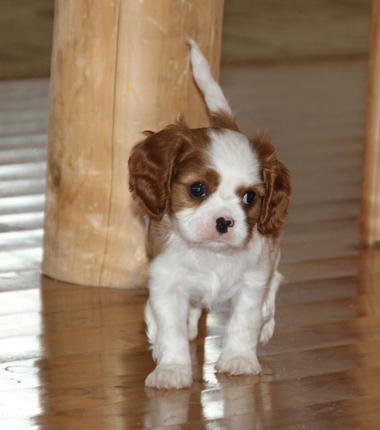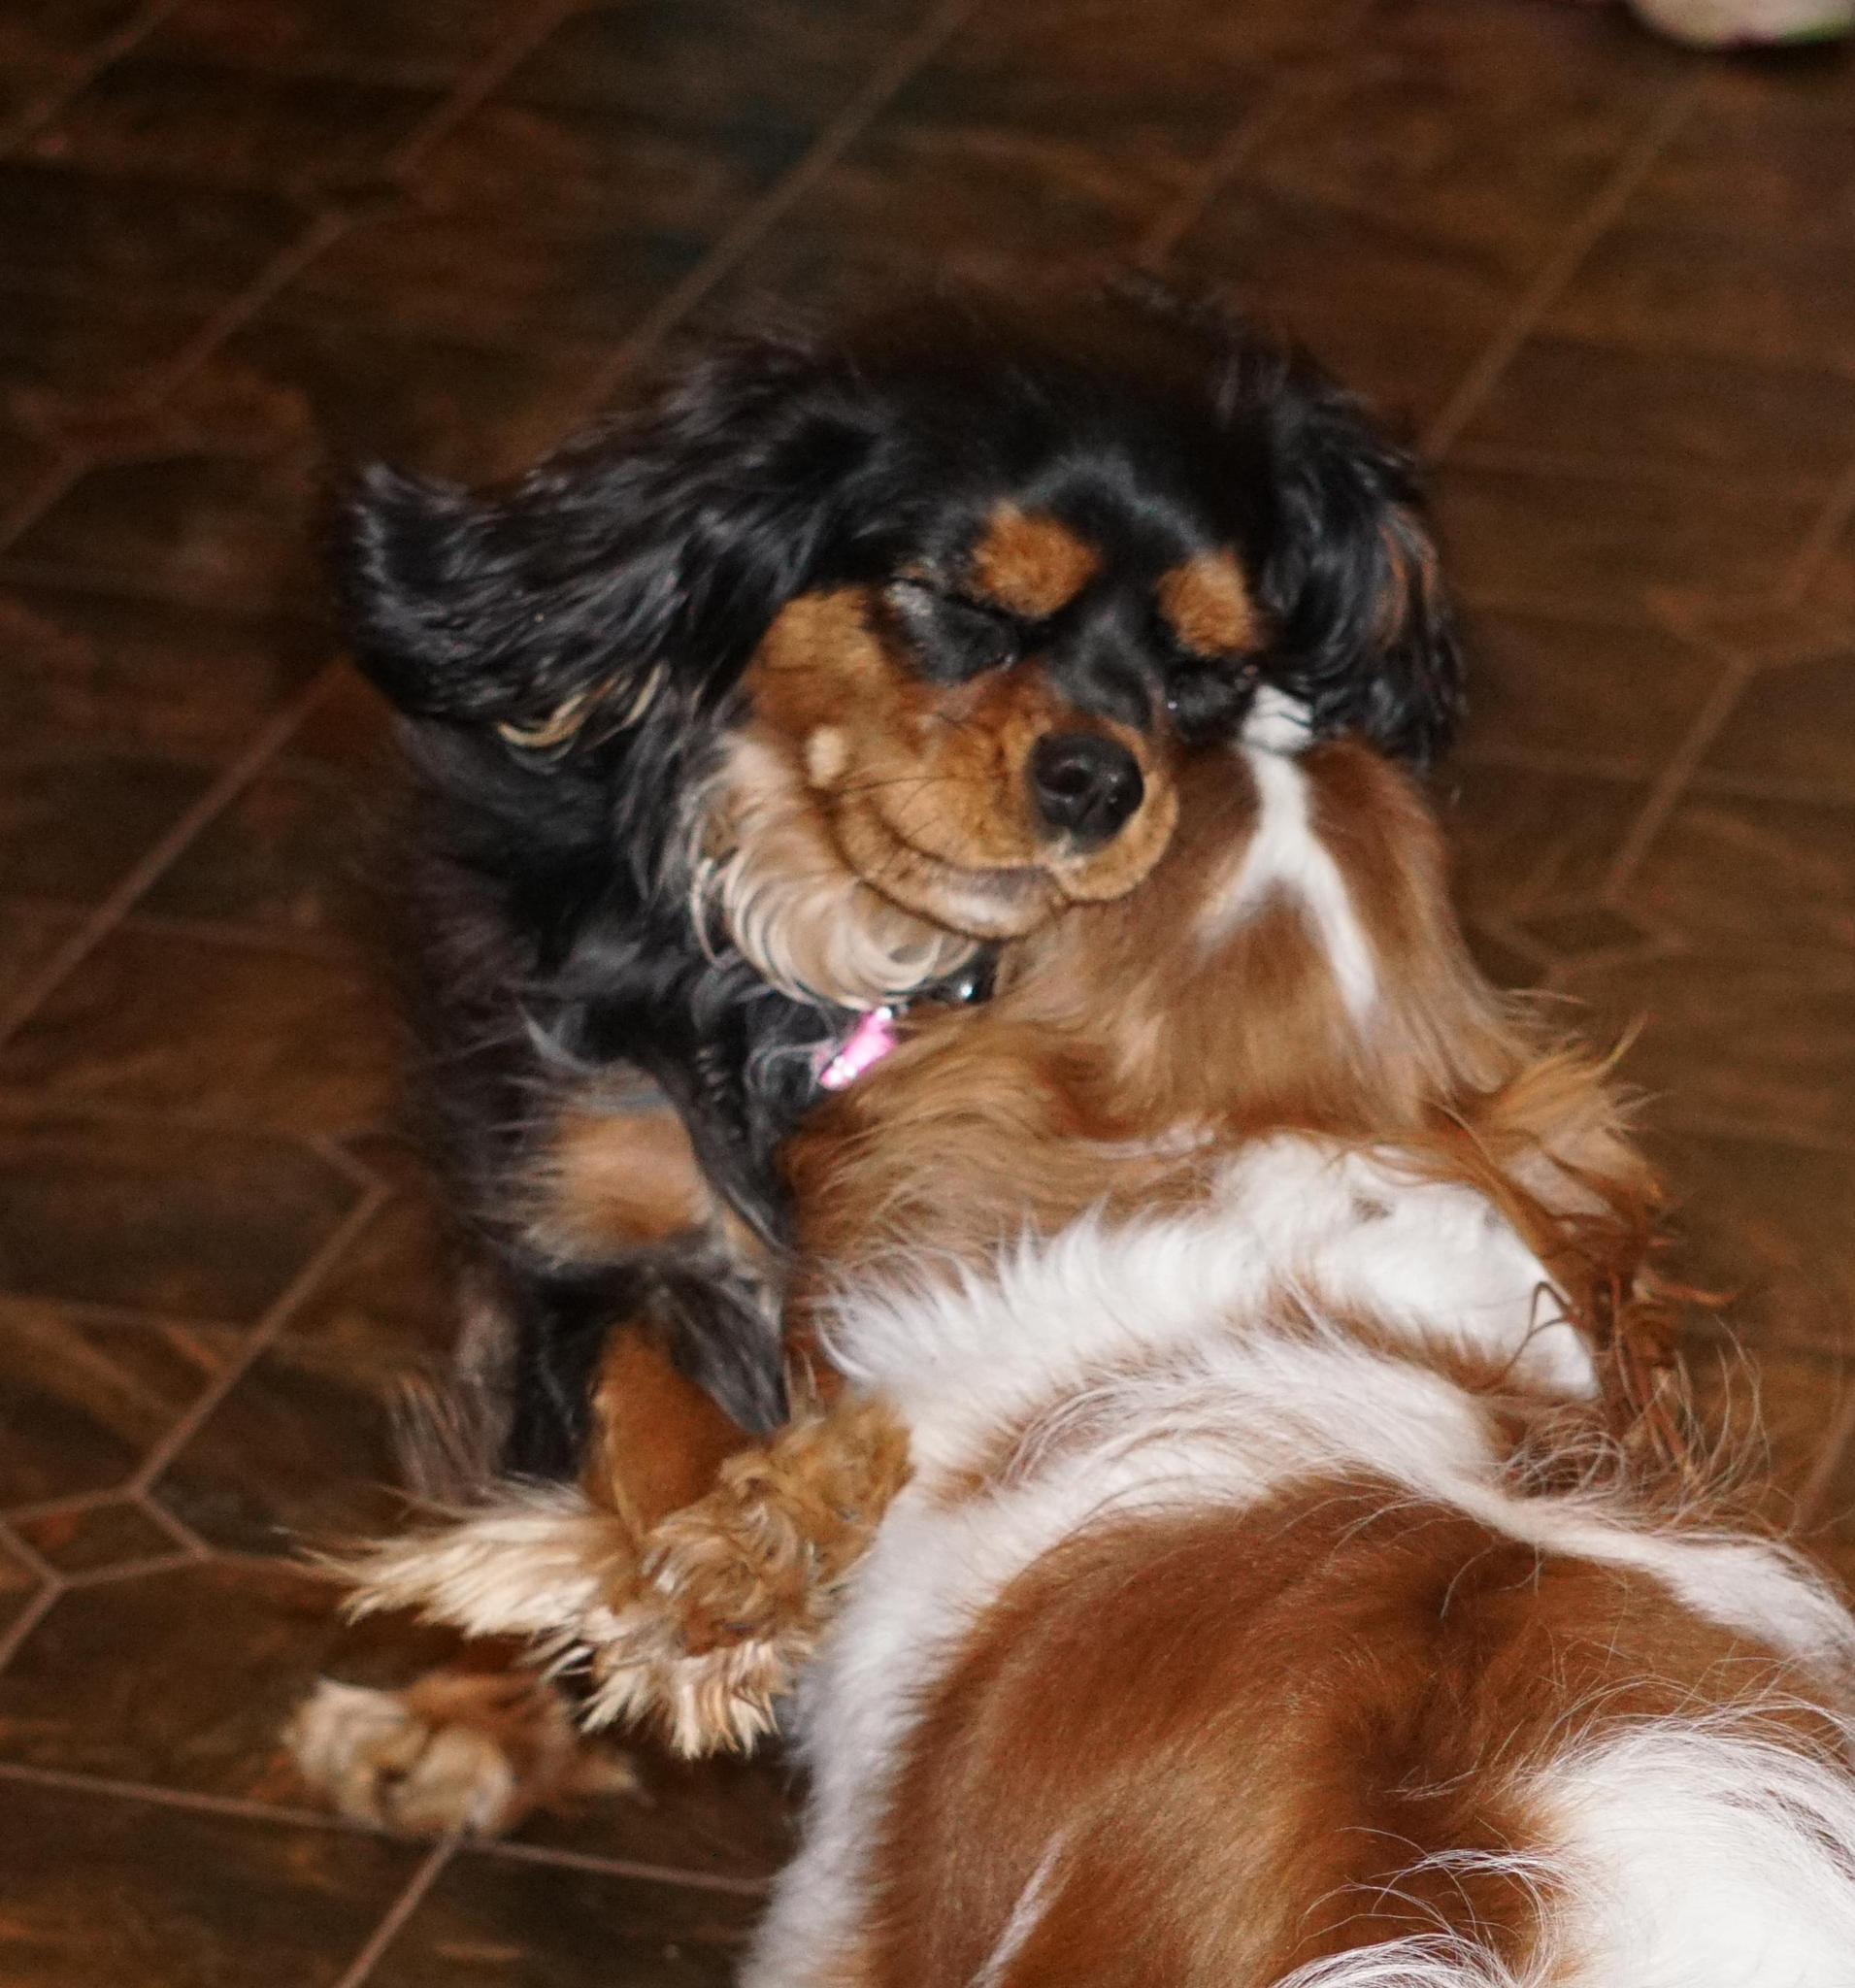The first image is the image on the left, the second image is the image on the right. Evaluate the accuracy of this statement regarding the images: "The right image contains exactly four dogs seated in a horizontal row.". Is it true? Answer yes or no. No. The first image is the image on the left, the second image is the image on the right. Analyze the images presented: Is the assertion "A horizontal row of four spaniels in similar poses includes dogs of different colors." valid? Answer yes or no. No. 